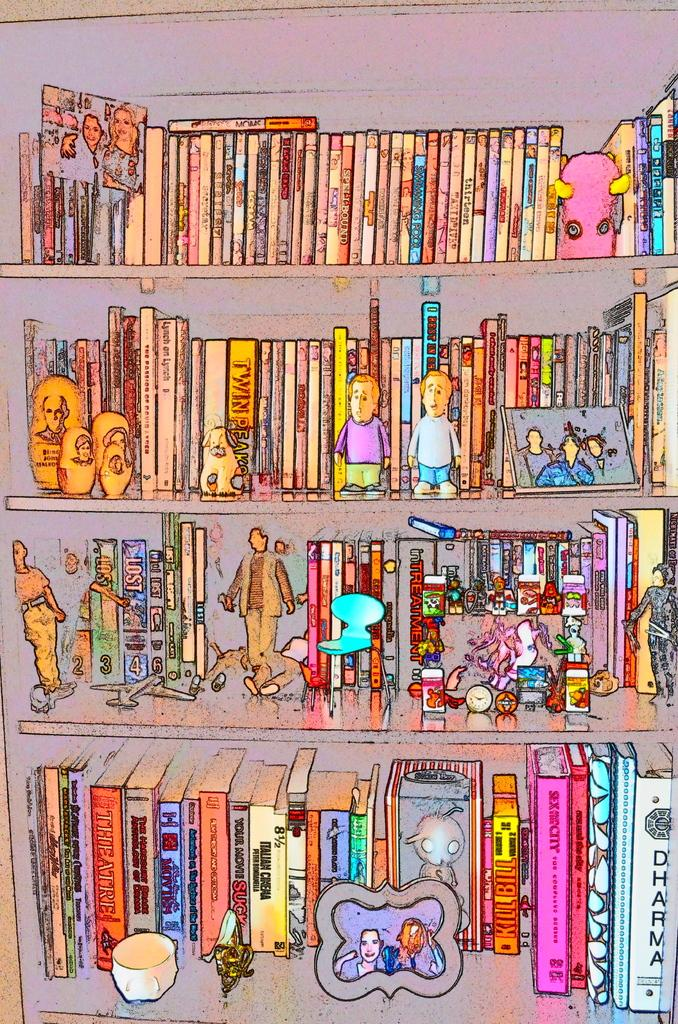Provide a one-sentence caption for the provided image. an abstract of a children's book shelf with titles like Dharma. 